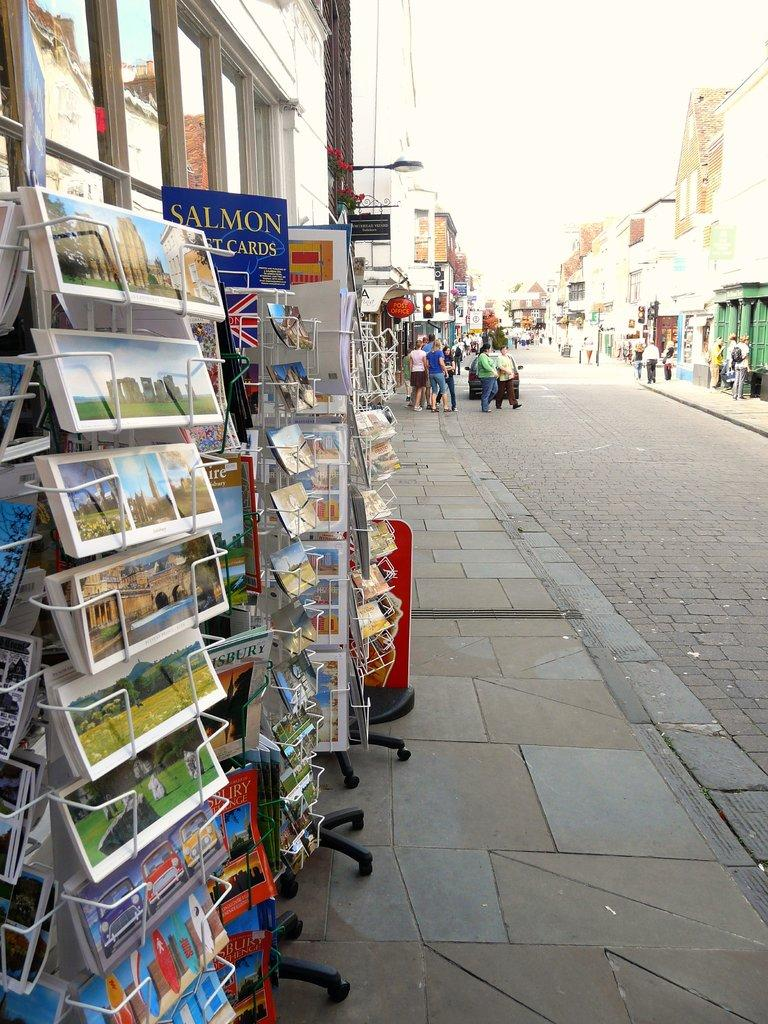<image>
Share a concise interpretation of the image provided. Racks of postcards, one rack labeled Salmon, sits on a sidewalk outside of a store. 